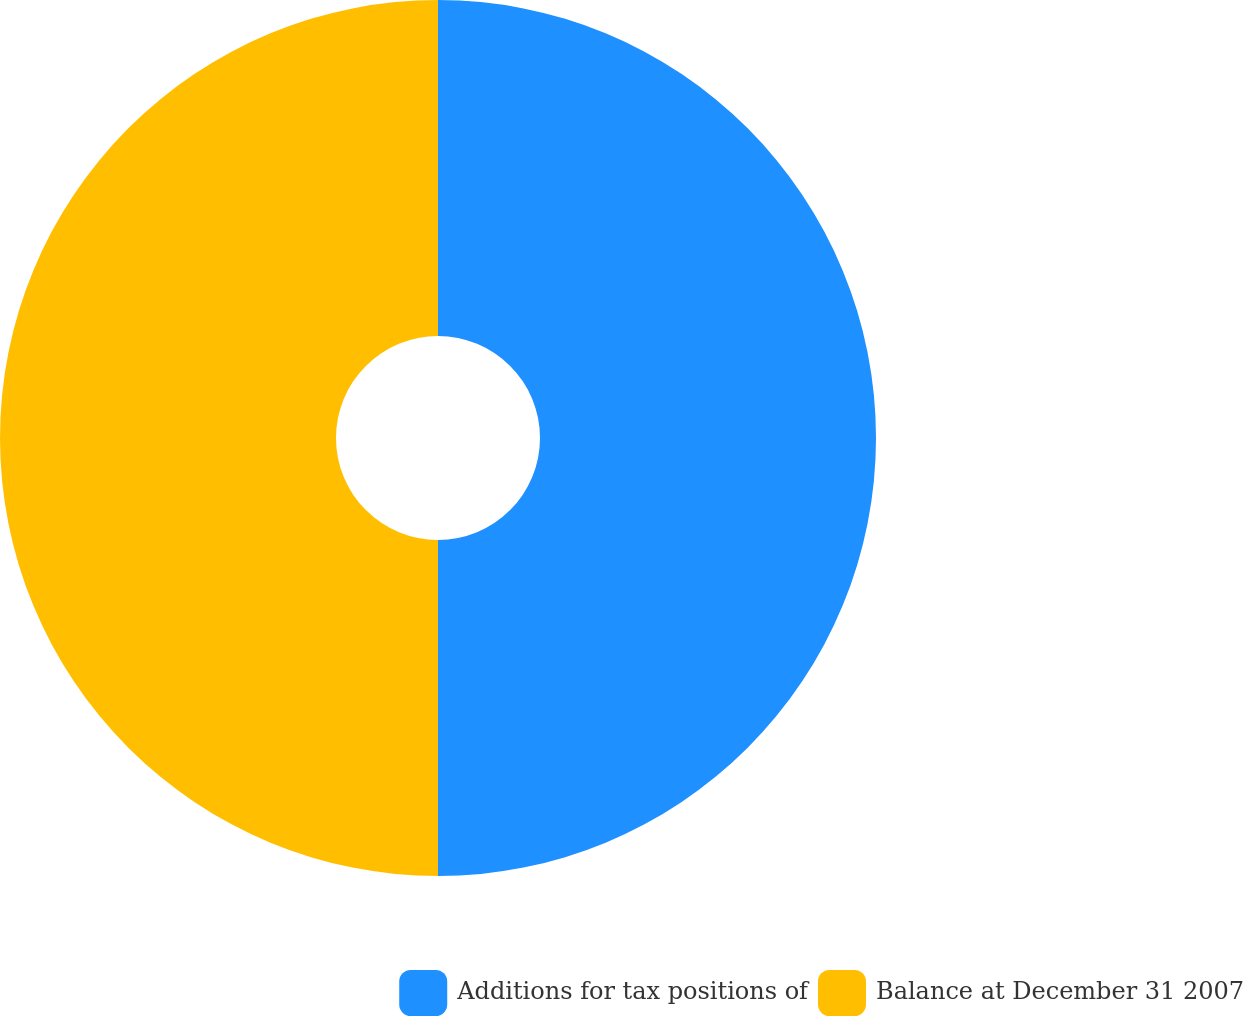Convert chart. <chart><loc_0><loc_0><loc_500><loc_500><pie_chart><fcel>Additions for tax positions of<fcel>Balance at December 31 2007<nl><fcel>50.0%<fcel>50.0%<nl></chart> 